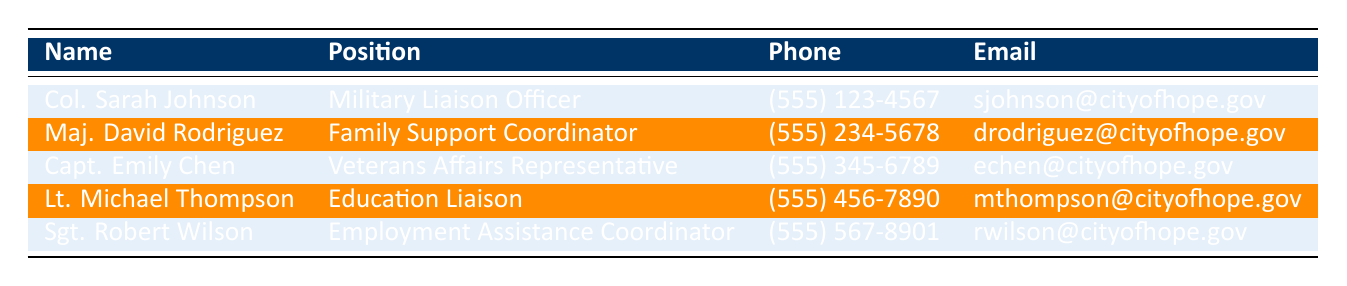What is the email address of the Family Support Coordinator? According to the table, the Family Support Coordinator is Maj. David Rodriguez, and his email address is listed as drodriguez@cityofhope.gov.
Answer: drodriguez@cityofhope.gov What is the phone number of Col. Sarah Johnson? The table states that Col. Sarah Johnson's phone number is (555) 123-4567.
Answer: (555) 123-4567 Is Capt. Emily Chen the Employment Assistance Coordinator? The table indicates that Capt. Emily Chen holds the position of Veterans Affairs Representative, not Employment Assistance Coordinator.
Answer: No How many military liaison personnel are listed in the table? There are five names listed in the table, each representing a different position related to military liaison activities in the city.
Answer: 5 Which position has the phone number (555) 456-7890? The table shows that the phone number (555) 456-7890 belongs to Lt. Michael Thompson, who is the Education Liaison.
Answer: Education Liaison What is the name of the person who works as an Employment Assistance Coordinator? Referring to the table, the Employment Assistance Coordinator is identified as Sgt. Robert Wilson.
Answer: Sgt. Robert Wilson Are there more than two people listed as liaisons in this table? The table provides a total of five personnel names, indicating that there are indeed more than two liaisons listed.
Answer: Yes What are the positions held by personnel with phone numbers starting with (555) 234 and (555) 567? The phone number (555) 234 is associated with Maj. David Rodriguez, Family Support Coordinator, and (555) 567 is linked to Sgt. Robert Wilson, Employment Assistance Coordinator.
Answer: Family Support Coordinator; Employment Assistance Coordinator Which position is held by the person with the email sjohnson@cityofhope.gov? The email address sjohnson@cityofhope.gov corresponds to Col. Sarah Johnson, who is the Military Liaison Officer according to the table.
Answer: Military Liaison Officer 